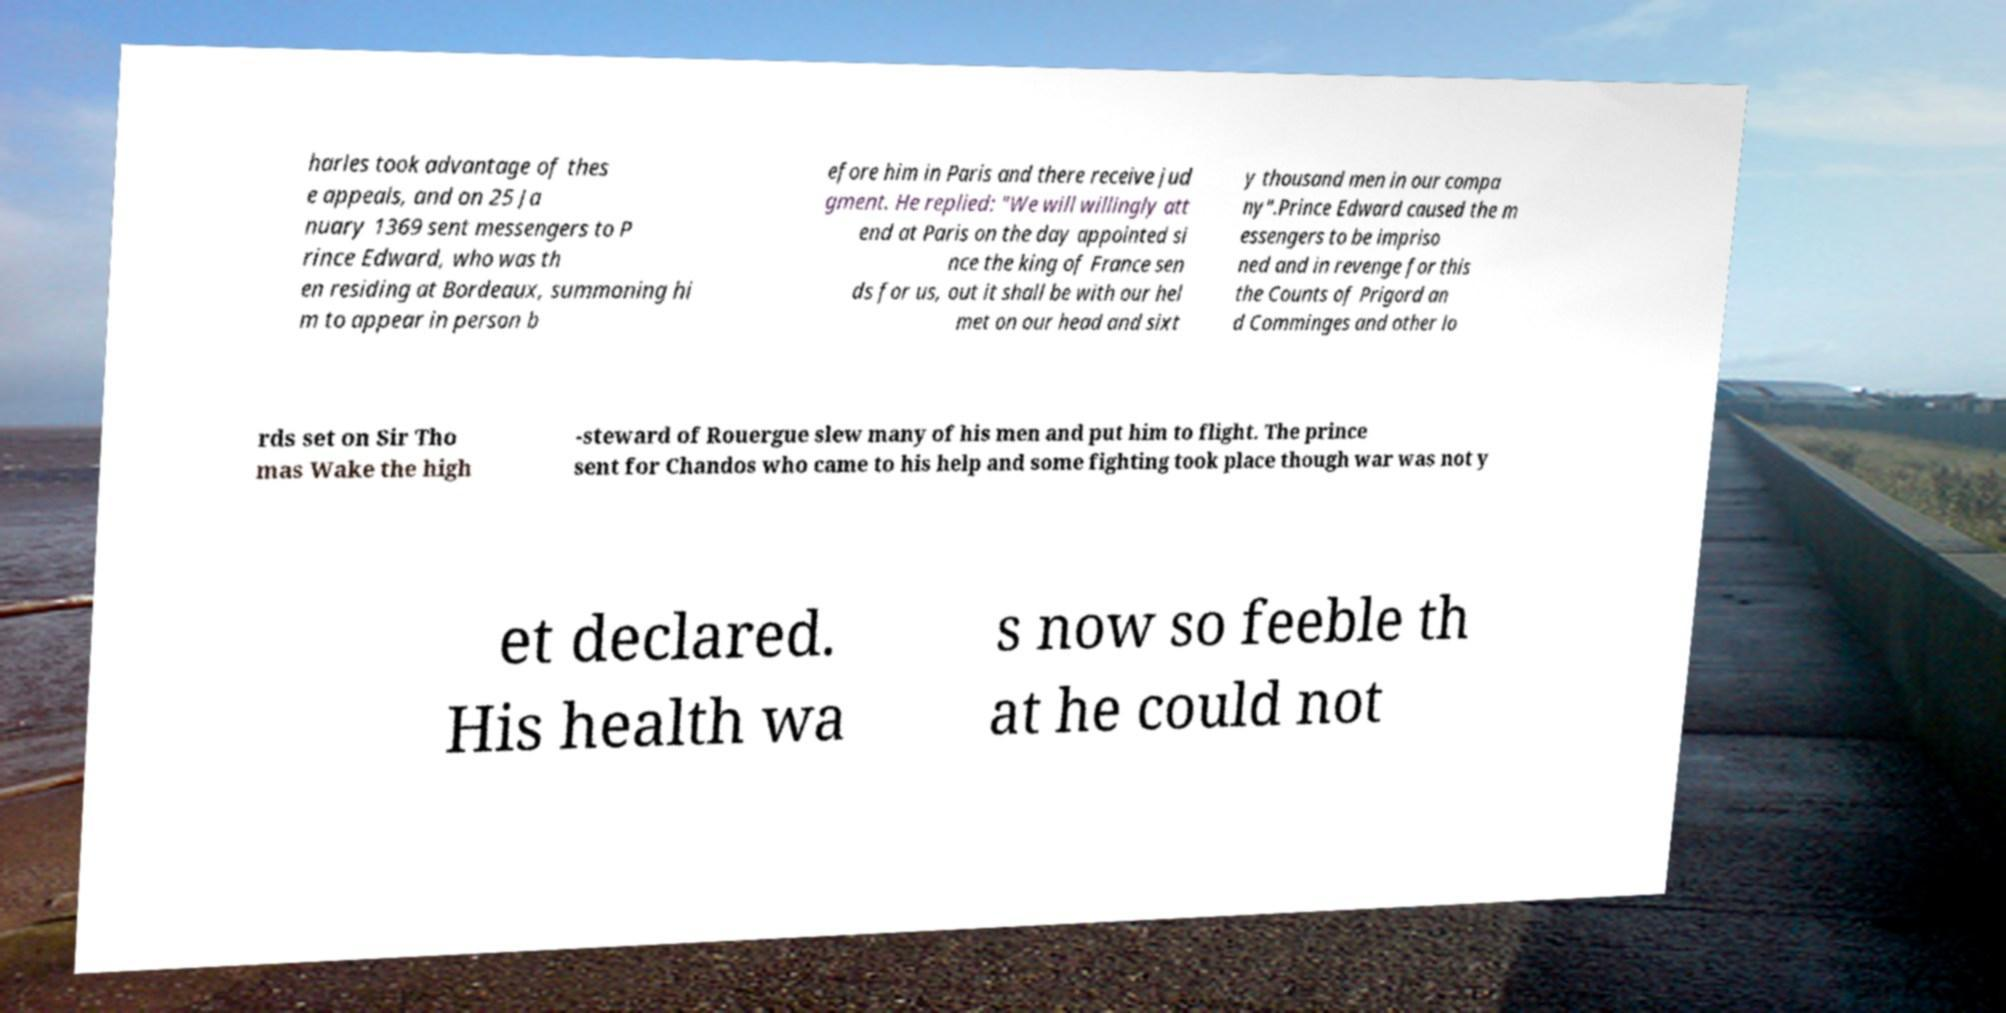There's text embedded in this image that I need extracted. Can you transcribe it verbatim? harles took advantage of thes e appeals, and on 25 Ja nuary 1369 sent messengers to P rince Edward, who was th en residing at Bordeaux, summoning hi m to appear in person b efore him in Paris and there receive jud gment. He replied: "We will willingly att end at Paris on the day appointed si nce the king of France sen ds for us, out it shall be with our hel met on our head and sixt y thousand men in our compa ny".Prince Edward caused the m essengers to be impriso ned and in revenge for this the Counts of Prigord an d Comminges and other lo rds set on Sir Tho mas Wake the high -steward of Rouergue slew many of his men and put him to flight. The prince sent for Chandos who came to his help and some fighting took place though war was not y et declared. His health wa s now so feeble th at he could not 